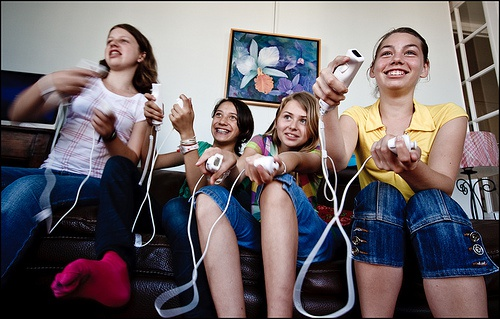Describe the objects in this image and their specific colors. I can see people in black, gray, navy, and pink tones, people in black, darkgray, and gray tones, couch in black, gray, navy, and white tones, people in black, darkgray, lavender, and navy tones, and people in black, lightgray, gray, and maroon tones in this image. 